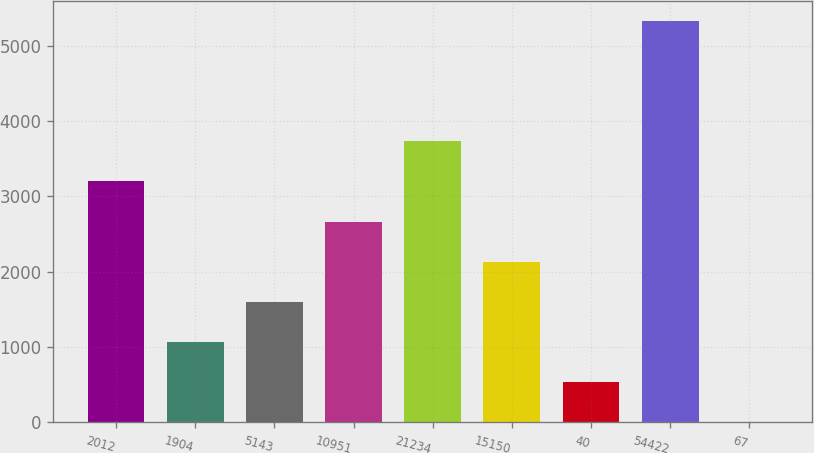<chart> <loc_0><loc_0><loc_500><loc_500><bar_chart><fcel>2012<fcel>1904<fcel>5143<fcel>10951<fcel>21234<fcel>15150<fcel>40<fcel>54422<fcel>67<nl><fcel>3199.58<fcel>1070.46<fcel>1602.74<fcel>2667.3<fcel>3731.86<fcel>2135.02<fcel>538.18<fcel>5328.7<fcel>5.9<nl></chart> 